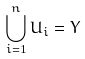Convert formula to latex. <formula><loc_0><loc_0><loc_500><loc_500>\bigcup _ { i = 1 } ^ { n } U _ { i } = Y</formula> 